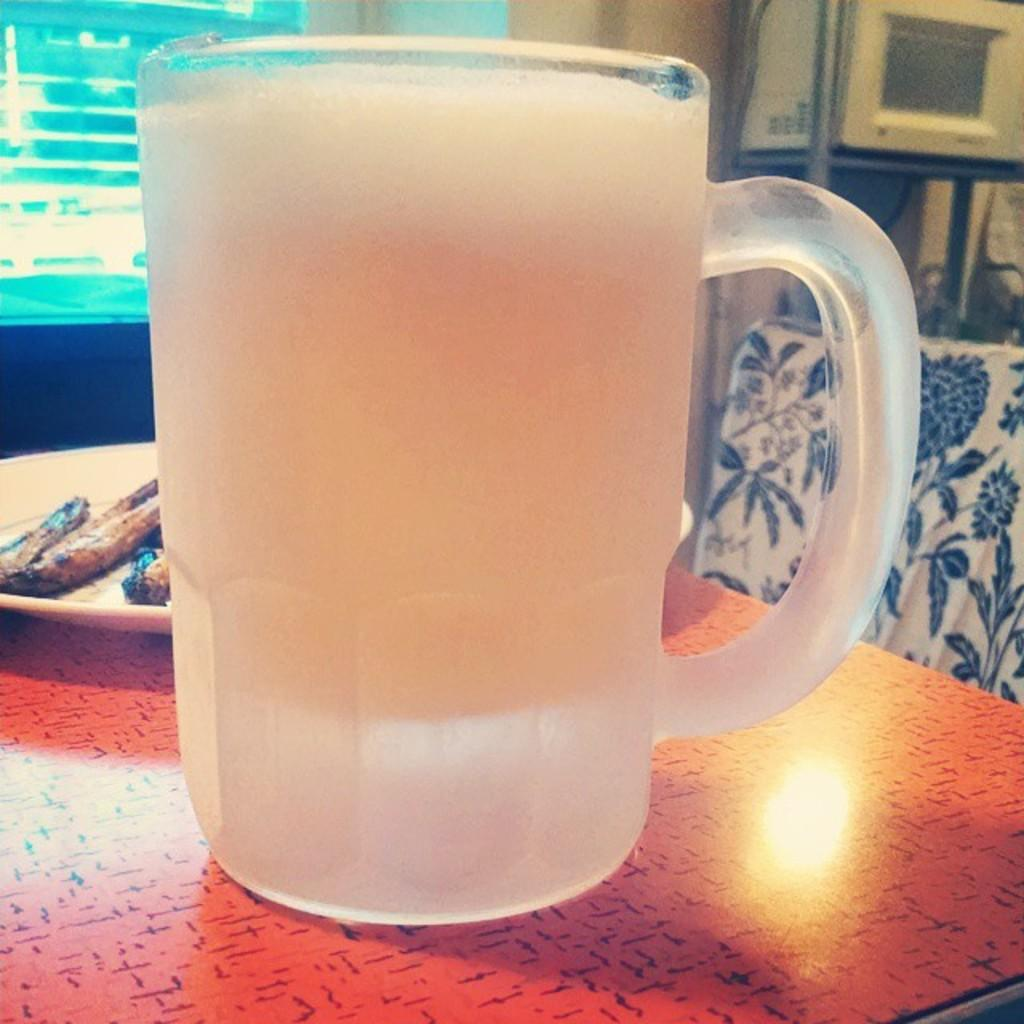What object is in the middle of the image? There is a mug in the middle of the image. Where is the mug located? The mug is placed on a table. What other object is on the table in the image? There is a plate in the image, and it is also on the table. How many shoes are visible in the image? There are no shoes present in the image. What type of bomb can be seen on the table in the image? There is no bomb present in the image; it features a mug and a plate on a table. 